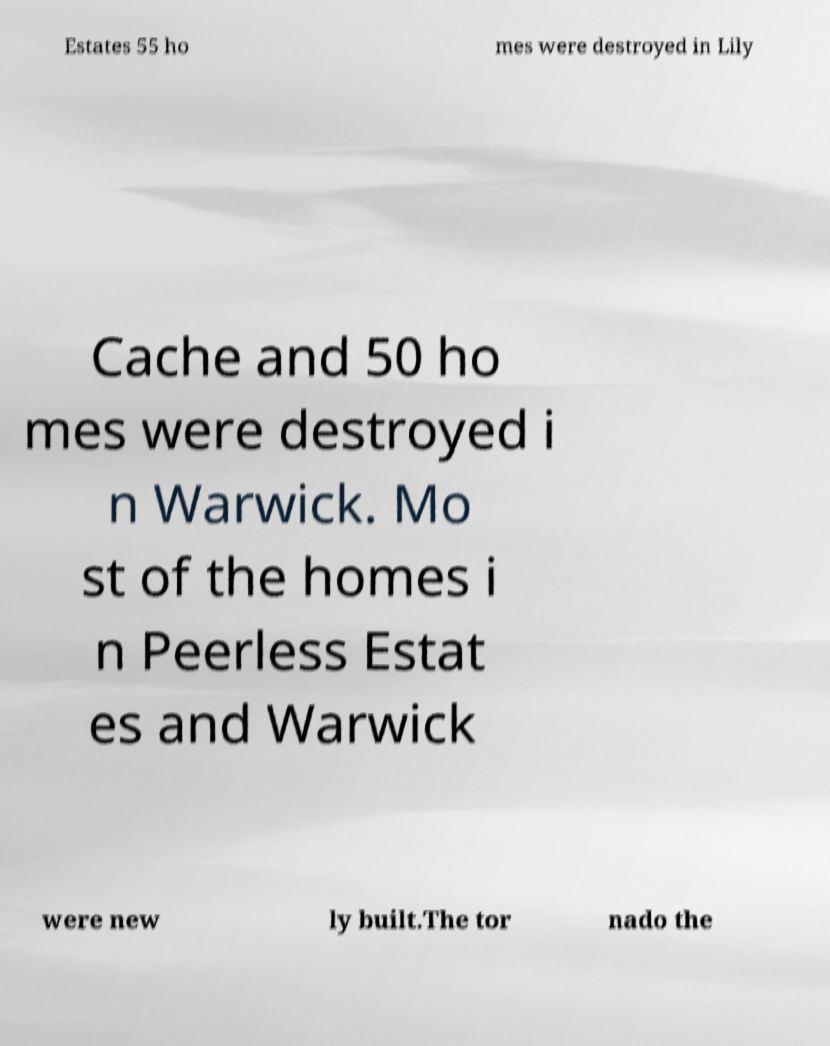There's text embedded in this image that I need extracted. Can you transcribe it verbatim? Estates 55 ho mes were destroyed in Lily Cache and 50 ho mes were destroyed i n Warwick. Mo st of the homes i n Peerless Estat es and Warwick were new ly built.The tor nado the 